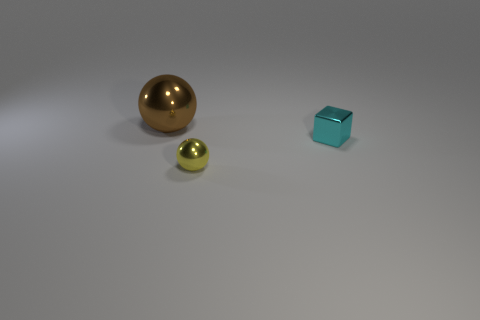Subtract 0 red spheres. How many objects are left? 3 Subtract all cubes. How many objects are left? 2 Subtract 1 blocks. How many blocks are left? 0 Subtract all cyan spheres. Subtract all yellow cylinders. How many spheres are left? 2 Subtract all gray cylinders. How many yellow balls are left? 1 Subtract all big metallic things. Subtract all small shiny spheres. How many objects are left? 1 Add 2 tiny cyan metal objects. How many tiny cyan metal objects are left? 3 Add 3 blue cylinders. How many blue cylinders exist? 3 Add 1 small brown rubber things. How many objects exist? 4 Subtract all brown balls. How many balls are left? 1 